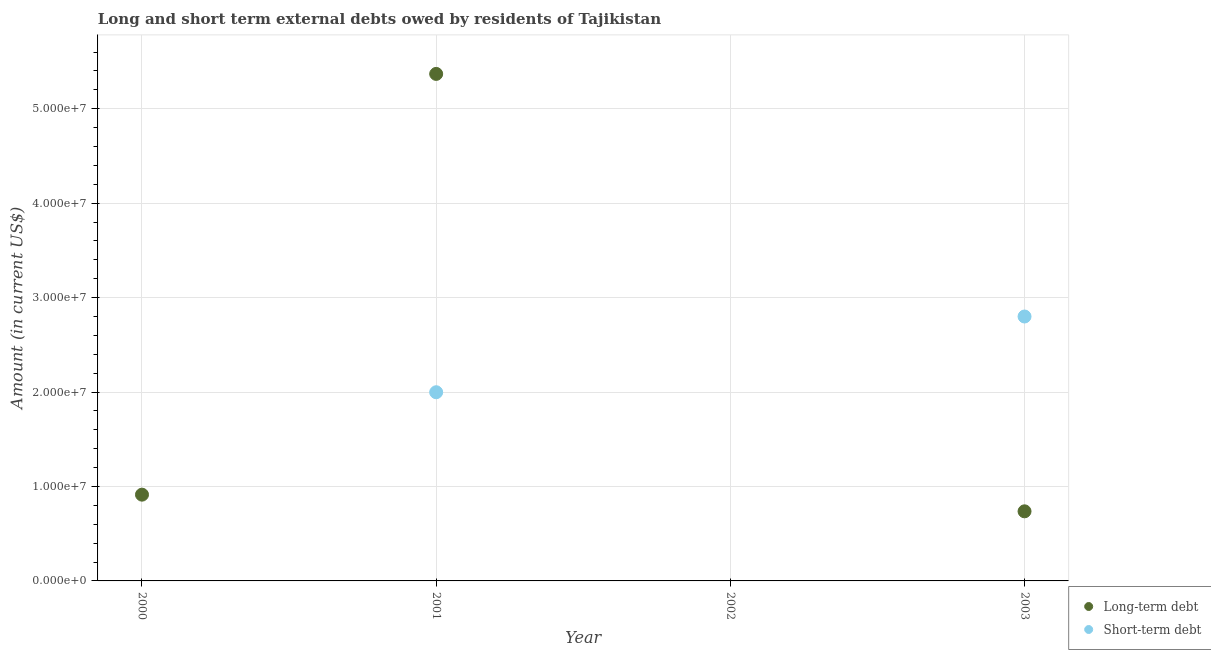How many different coloured dotlines are there?
Provide a short and direct response. 2. Is the number of dotlines equal to the number of legend labels?
Offer a very short reply. No. What is the long-term debts owed by residents in 2000?
Offer a very short reply. 9.14e+06. Across all years, what is the maximum short-term debts owed by residents?
Make the answer very short. 2.80e+07. Across all years, what is the minimum short-term debts owed by residents?
Offer a terse response. 0. What is the total short-term debts owed by residents in the graph?
Provide a succinct answer. 4.80e+07. What is the difference between the long-term debts owed by residents in 2000 and that in 2001?
Your answer should be compact. -4.46e+07. What is the difference between the short-term debts owed by residents in 2002 and the long-term debts owed by residents in 2000?
Your answer should be compact. -9.14e+06. What is the average short-term debts owed by residents per year?
Ensure brevity in your answer.  1.20e+07. In the year 2003, what is the difference between the short-term debts owed by residents and long-term debts owed by residents?
Keep it short and to the point. 2.06e+07. In how many years, is the short-term debts owed by residents greater than 50000000 US$?
Keep it short and to the point. 0. What is the ratio of the long-term debts owed by residents in 2001 to that in 2003?
Your answer should be compact. 7.28. What is the difference between the highest and the second highest long-term debts owed by residents?
Ensure brevity in your answer.  4.46e+07. What is the difference between the highest and the lowest long-term debts owed by residents?
Provide a short and direct response. 5.37e+07. In how many years, is the short-term debts owed by residents greater than the average short-term debts owed by residents taken over all years?
Offer a terse response. 2. Is the short-term debts owed by residents strictly less than the long-term debts owed by residents over the years?
Give a very brief answer. No. How many dotlines are there?
Ensure brevity in your answer.  2. How many years are there in the graph?
Keep it short and to the point. 4. What is the difference between two consecutive major ticks on the Y-axis?
Your response must be concise. 1.00e+07. Does the graph contain any zero values?
Keep it short and to the point. Yes. Where does the legend appear in the graph?
Provide a short and direct response. Bottom right. How many legend labels are there?
Your response must be concise. 2. What is the title of the graph?
Make the answer very short. Long and short term external debts owed by residents of Tajikistan. Does "Forest land" appear as one of the legend labels in the graph?
Keep it short and to the point. No. What is the label or title of the Y-axis?
Your response must be concise. Amount (in current US$). What is the Amount (in current US$) in Long-term debt in 2000?
Your answer should be very brief. 9.14e+06. What is the Amount (in current US$) in Short-term debt in 2000?
Your answer should be very brief. 0. What is the Amount (in current US$) of Long-term debt in 2001?
Make the answer very short. 5.37e+07. What is the Amount (in current US$) of Short-term debt in 2001?
Give a very brief answer. 2.00e+07. What is the Amount (in current US$) in Long-term debt in 2002?
Offer a very short reply. 0. What is the Amount (in current US$) of Long-term debt in 2003?
Offer a terse response. 7.37e+06. What is the Amount (in current US$) of Short-term debt in 2003?
Provide a succinct answer. 2.80e+07. Across all years, what is the maximum Amount (in current US$) of Long-term debt?
Offer a very short reply. 5.37e+07. Across all years, what is the maximum Amount (in current US$) in Short-term debt?
Ensure brevity in your answer.  2.80e+07. Across all years, what is the minimum Amount (in current US$) in Long-term debt?
Your response must be concise. 0. Across all years, what is the minimum Amount (in current US$) in Short-term debt?
Your answer should be very brief. 0. What is the total Amount (in current US$) of Long-term debt in the graph?
Give a very brief answer. 7.02e+07. What is the total Amount (in current US$) in Short-term debt in the graph?
Keep it short and to the point. 4.80e+07. What is the difference between the Amount (in current US$) in Long-term debt in 2000 and that in 2001?
Provide a short and direct response. -4.46e+07. What is the difference between the Amount (in current US$) in Long-term debt in 2000 and that in 2003?
Your answer should be compact. 1.76e+06. What is the difference between the Amount (in current US$) of Long-term debt in 2001 and that in 2003?
Ensure brevity in your answer.  4.63e+07. What is the difference between the Amount (in current US$) in Short-term debt in 2001 and that in 2003?
Provide a succinct answer. -8.02e+06. What is the difference between the Amount (in current US$) in Long-term debt in 2000 and the Amount (in current US$) in Short-term debt in 2001?
Your response must be concise. -1.08e+07. What is the difference between the Amount (in current US$) in Long-term debt in 2000 and the Amount (in current US$) in Short-term debt in 2003?
Your answer should be very brief. -1.89e+07. What is the difference between the Amount (in current US$) in Long-term debt in 2001 and the Amount (in current US$) in Short-term debt in 2003?
Provide a short and direct response. 2.57e+07. What is the average Amount (in current US$) of Long-term debt per year?
Offer a terse response. 1.75e+07. What is the average Amount (in current US$) of Short-term debt per year?
Your answer should be very brief. 1.20e+07. In the year 2001, what is the difference between the Amount (in current US$) in Long-term debt and Amount (in current US$) in Short-term debt?
Your answer should be very brief. 3.37e+07. In the year 2003, what is the difference between the Amount (in current US$) in Long-term debt and Amount (in current US$) in Short-term debt?
Offer a terse response. -2.06e+07. What is the ratio of the Amount (in current US$) of Long-term debt in 2000 to that in 2001?
Your response must be concise. 0.17. What is the ratio of the Amount (in current US$) in Long-term debt in 2000 to that in 2003?
Your response must be concise. 1.24. What is the ratio of the Amount (in current US$) of Long-term debt in 2001 to that in 2003?
Offer a terse response. 7.28. What is the ratio of the Amount (in current US$) of Short-term debt in 2001 to that in 2003?
Your answer should be compact. 0.71. What is the difference between the highest and the second highest Amount (in current US$) of Long-term debt?
Ensure brevity in your answer.  4.46e+07. What is the difference between the highest and the lowest Amount (in current US$) of Long-term debt?
Your answer should be compact. 5.37e+07. What is the difference between the highest and the lowest Amount (in current US$) in Short-term debt?
Ensure brevity in your answer.  2.80e+07. 